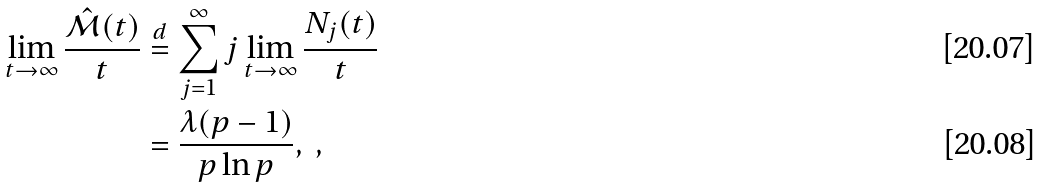Convert formula to latex. <formula><loc_0><loc_0><loc_500><loc_500>\lim _ { t \to \infty } \frac { \hat { \mathcal { M } } ( t ) } { t } & \stackrel { d } { = } \sum _ { j = 1 } ^ { \infty } j \lim _ { t \to \infty } \frac { N _ { j } ( t ) } { t } \\ & = \frac { \lambda ( p - 1 ) } { p \ln p } , \ ,</formula> 